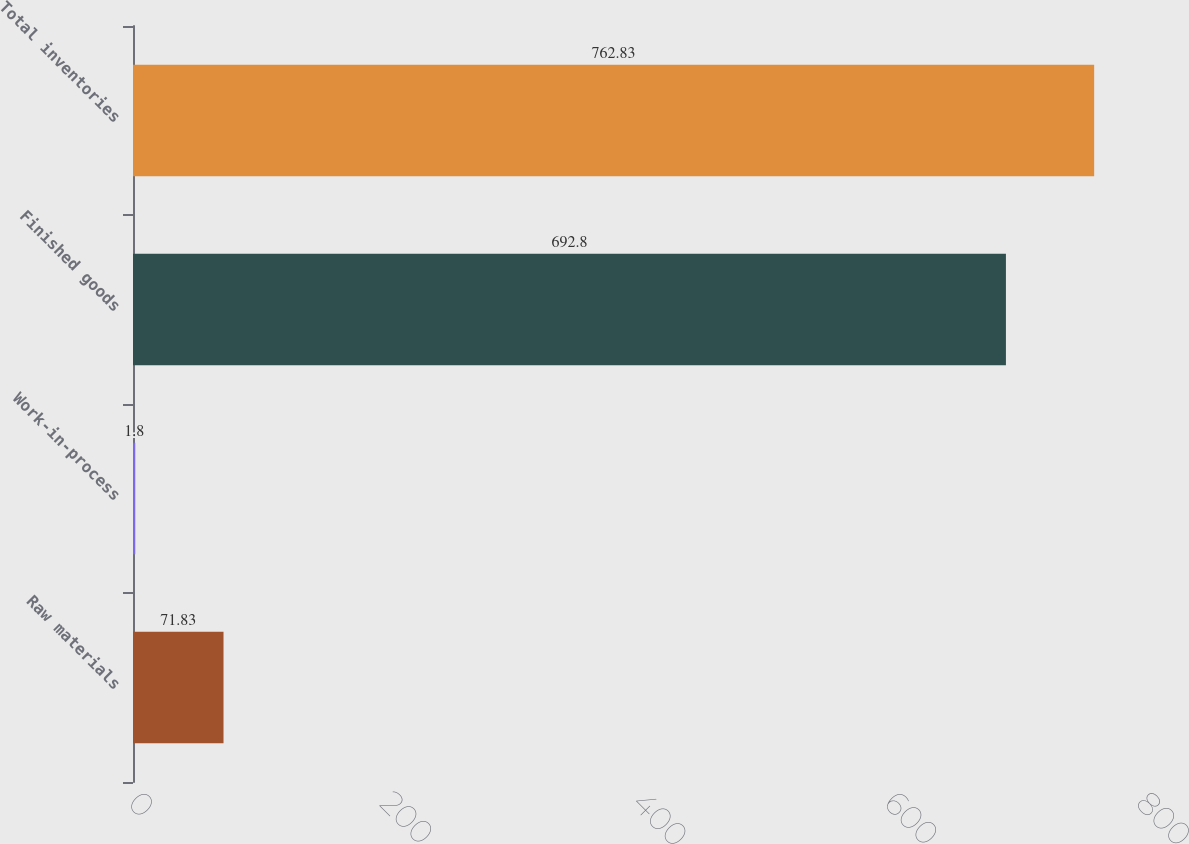Convert chart. <chart><loc_0><loc_0><loc_500><loc_500><bar_chart><fcel>Raw materials<fcel>Work-in-process<fcel>Finished goods<fcel>Total inventories<nl><fcel>71.83<fcel>1.8<fcel>692.8<fcel>762.83<nl></chart> 